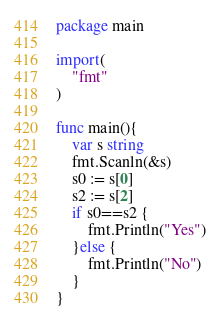Convert code to text. <code><loc_0><loc_0><loc_500><loc_500><_Go_>package main

import(
	"fmt"
)

func main(){
	var s string
	fmt.Scanln(&s)
	s0 := s[0]
	s2 := s[2]
	if s0==s2 {
		fmt.Println("Yes")
	}else {
		fmt.Println("No")
	}
}</code> 